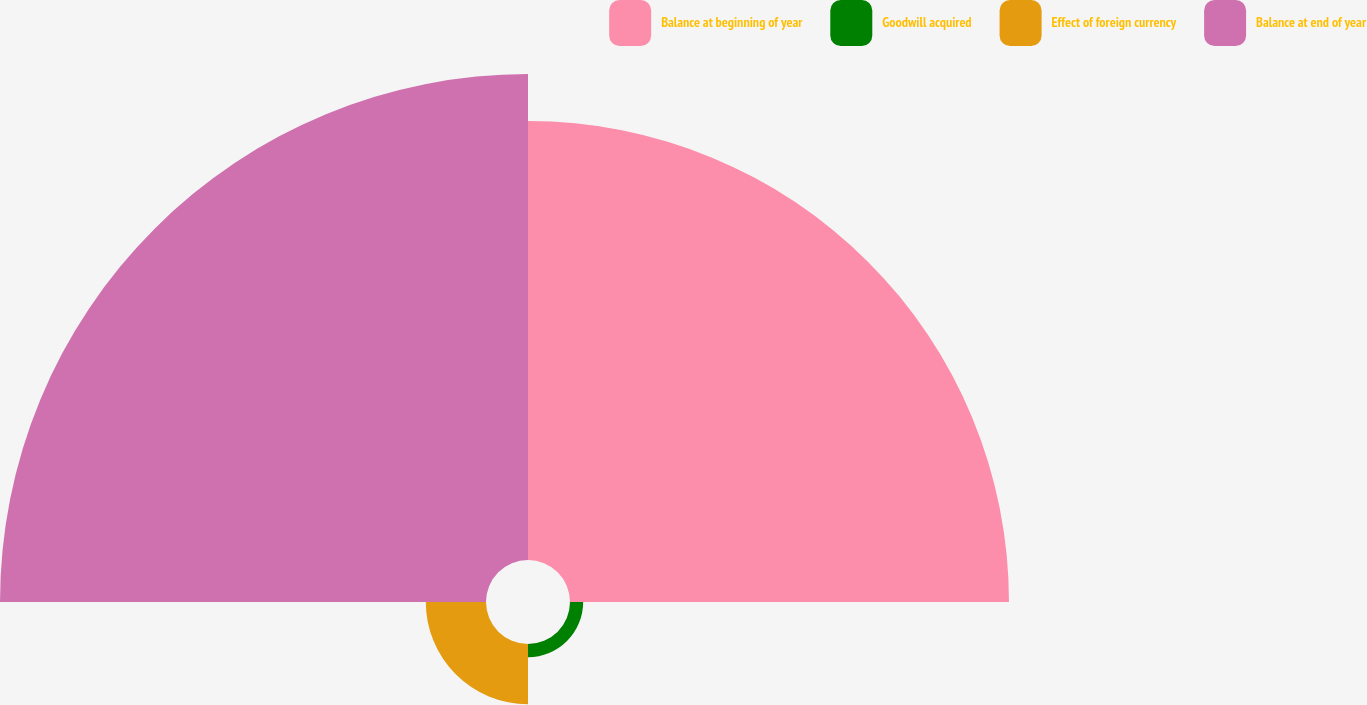Convert chart. <chart><loc_0><loc_0><loc_500><loc_500><pie_chart><fcel>Balance at beginning of year<fcel>Goodwill acquired<fcel>Effect of foreign currency<fcel>Balance at end of year<nl><fcel>43.97%<fcel>1.32%<fcel>6.03%<fcel>48.68%<nl></chart> 